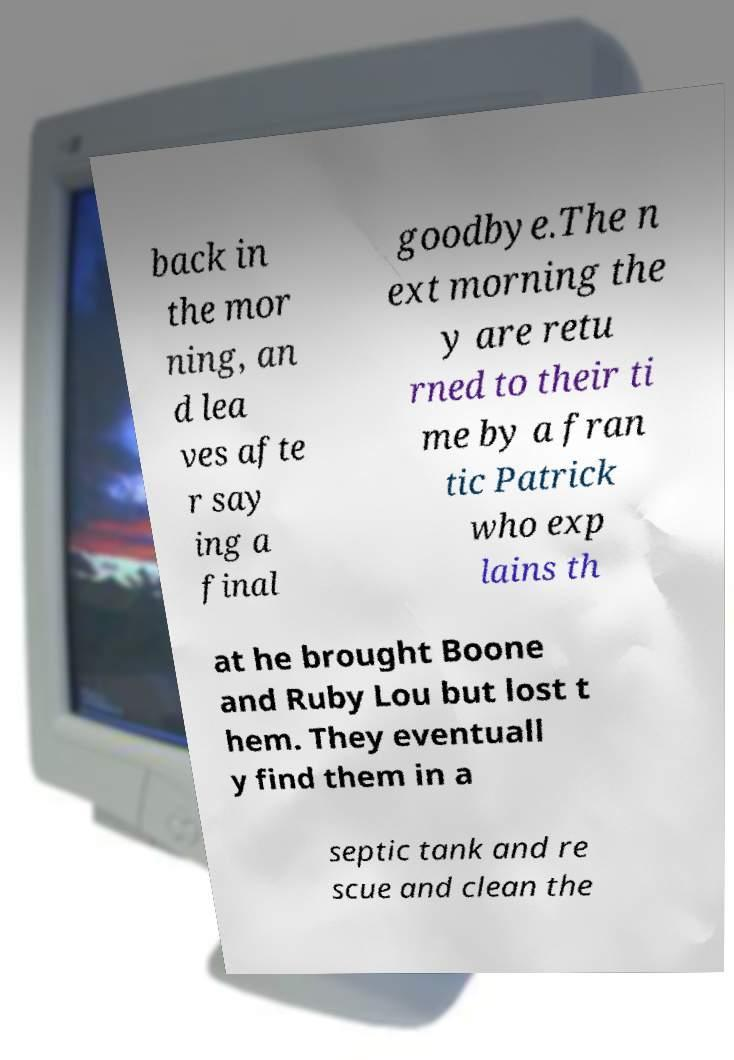I need the written content from this picture converted into text. Can you do that? back in the mor ning, an d lea ves afte r say ing a final goodbye.The n ext morning the y are retu rned to their ti me by a fran tic Patrick who exp lains th at he brought Boone and Ruby Lou but lost t hem. They eventuall y find them in a septic tank and re scue and clean the 